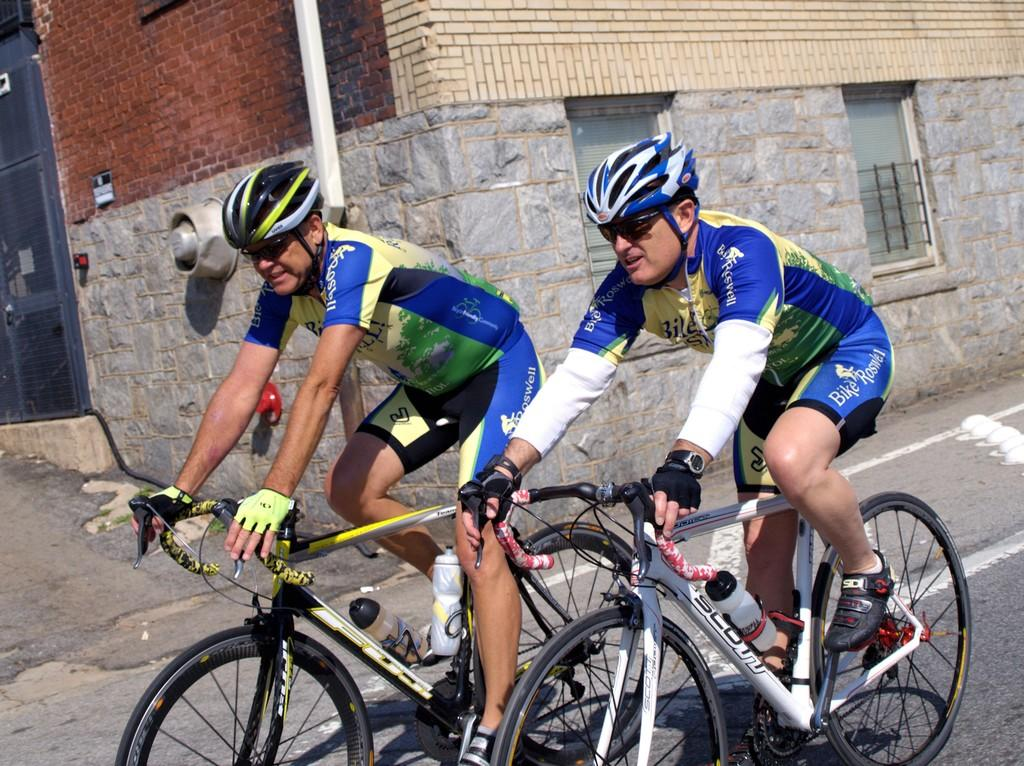How many people are in the image? There are two people in the image. What are the people doing in the image? The people are sitting on a bicycle. What safety precautions are the people taking in the image? The people are wearing helmets. What can be seen in terms of clothing in the image? The people are wearing different color dress. What type of structure is visible in the image? There is a building visible in the image. What is a notable feature of the building? The building has glass windows. What type of wall can be seen in the image? There is a brick wall in the image. What type of fuel is being used by the people on the bicycle in the image? There is no mention of fuel in the image, as the people are riding a bicycle, which does not require fuel. 